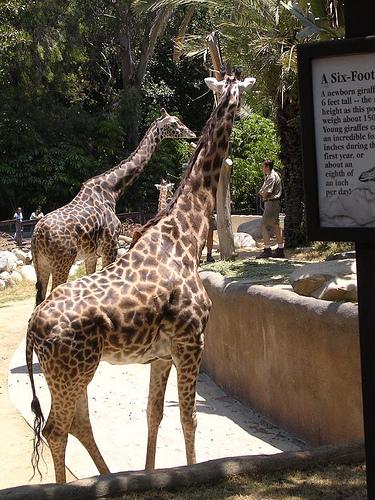How many animals are there?
Keep it brief. 3. Is this in a park?
Give a very brief answer. Yes. What kind of animals are these?
Answer briefly. Giraffe. 